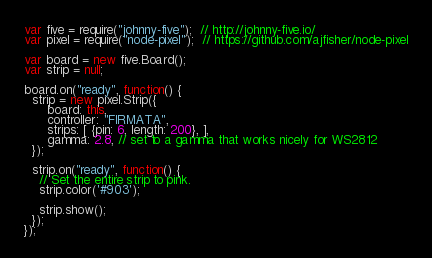<code> <loc_0><loc_0><loc_500><loc_500><_JavaScript_>var five = require("johnny-five");  // http://johnny-five.io/
var pixel = require("node-pixel");  // https://github.com/ajfisher/node-pixel

var board = new five.Board();
var strip = null;

board.on("ready", function() {
  strip = new pixel.Strip({
      board: this,
      controller: "FIRMATA",
      strips: [ {pin: 6, length: 200}, ],
      gamma: 2.8, // set to a gamma that works nicely for WS2812
  });

  strip.on("ready", function() {
    // Set the entire strip to pink.
    strip.color('#903');

    strip.show();
  });
});
</code> 